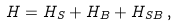Convert formula to latex. <formula><loc_0><loc_0><loc_500><loc_500>H = H _ { S } + H _ { B } + H _ { S B } \, ,</formula> 